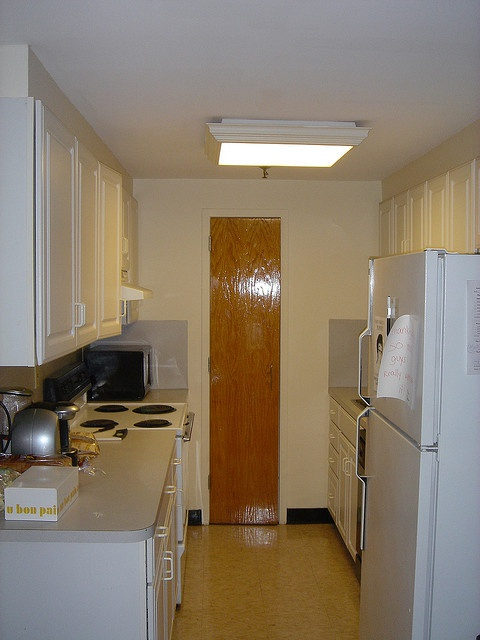Describe the objects in this image and their specific colors. I can see refrigerator in gray and darkgray tones, oven in gray, black, tan, and olive tones, microwave in gray and black tones, and sink in gray, black, olive, and maroon tones in this image. 